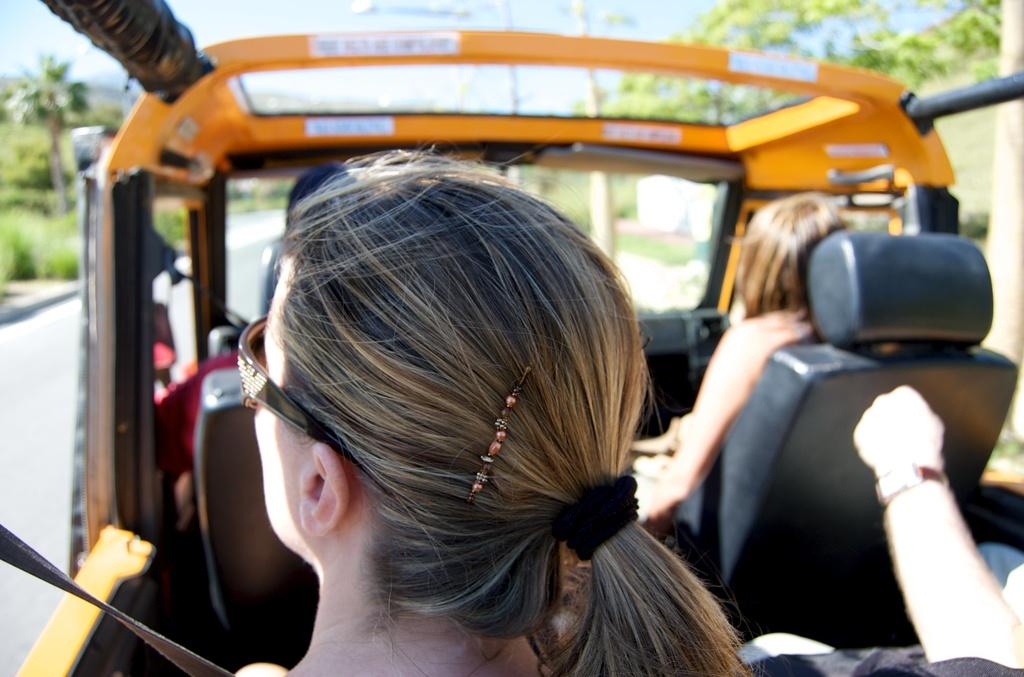What are the people in the image doing? The people in the image are traveling in a vehicle. What can be seen in the background of the image? There are trees and the sky visible in the background of the image. What is on the left side of the image? There is a road on the left side of the image. What type of beef is being served at the restaurant in the image? There is no restaurant or beef present in the image; it features people traveling in a vehicle with trees and the sky in the background. 